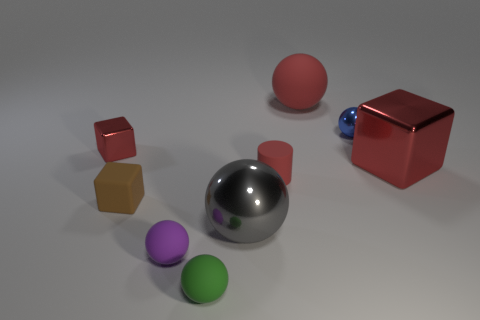There is a big red matte object; does it have the same shape as the small metallic object that is on the right side of the small purple rubber ball?
Provide a short and direct response. Yes. Is the number of small purple rubber balls greater than the number of big spheres?
Offer a very short reply. No. There is a small metallic object that is to the right of the gray metal object; is its shape the same as the tiny red matte thing?
Provide a succinct answer. No. Is the number of gray shiny objects in front of the small blue metallic sphere greater than the number of big blue matte objects?
Your response must be concise. Yes. There is a small object that is right of the matte sphere that is behind the small purple matte thing; what color is it?
Make the answer very short. Blue. How many gray matte cylinders are there?
Make the answer very short. 0. What number of things are both behind the big red metal object and to the left of the small purple rubber object?
Provide a short and direct response. 1. Is there anything else that is the same shape as the small red rubber thing?
Offer a terse response. No. There is a rubber cylinder; is it the same color as the tiny metal object on the left side of the small blue shiny thing?
Offer a very short reply. Yes. The red matte object that is on the right side of the small red cylinder has what shape?
Ensure brevity in your answer.  Sphere. 